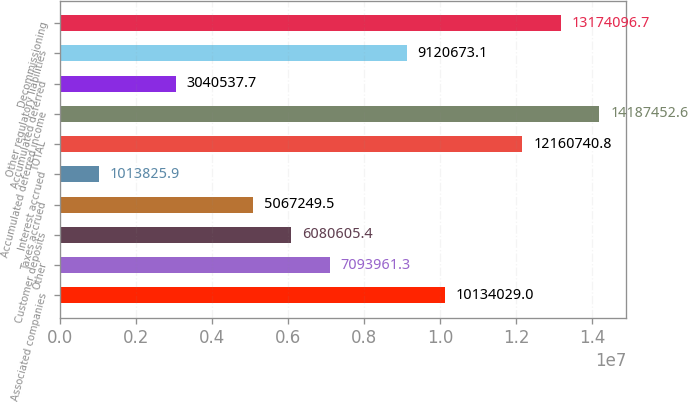Convert chart to OTSL. <chart><loc_0><loc_0><loc_500><loc_500><bar_chart><fcel>Associated companies<fcel>Other<fcel>Customer deposits<fcel>Taxes accrued<fcel>Interest accrued<fcel>TOTAL<fcel>Accumulated deferred income<fcel>Accumulated deferred<fcel>Other regulatory liabilities<fcel>Decommissioning<nl><fcel>1.0134e+07<fcel>7.09396e+06<fcel>6.08061e+06<fcel>5.06725e+06<fcel>1.01383e+06<fcel>1.21607e+07<fcel>1.41875e+07<fcel>3.04054e+06<fcel>9.12067e+06<fcel>1.31741e+07<nl></chart> 